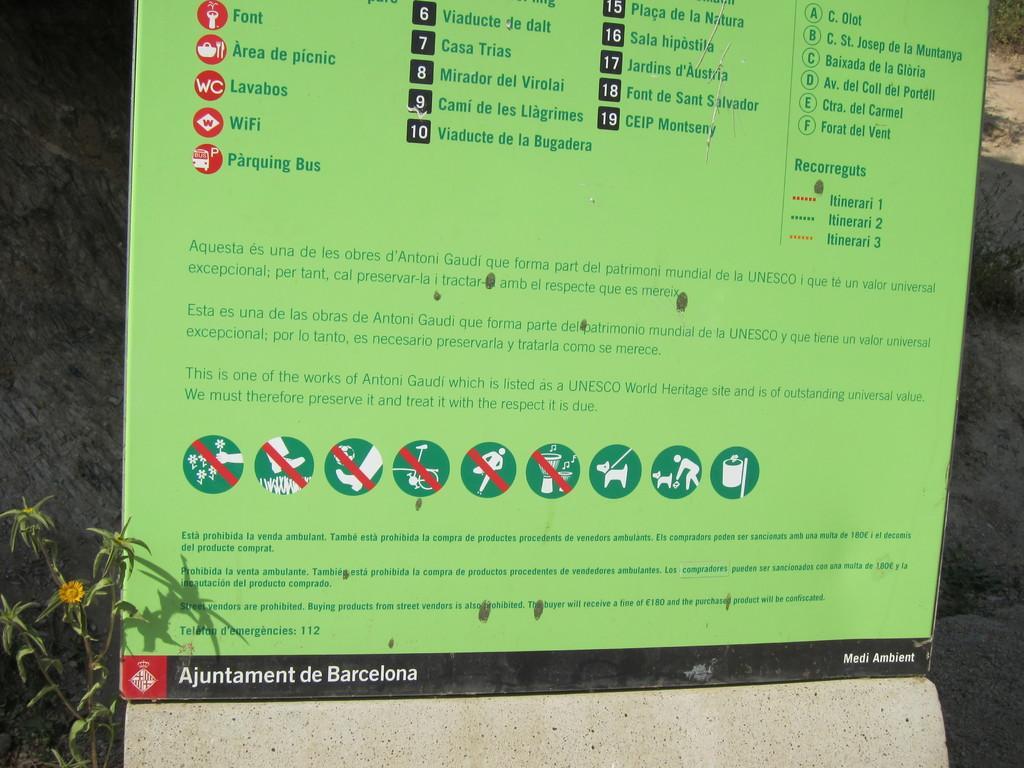How would you summarize this image in a sentence or two? It is a paper with instructions in green color. On the left side there is a plant. 